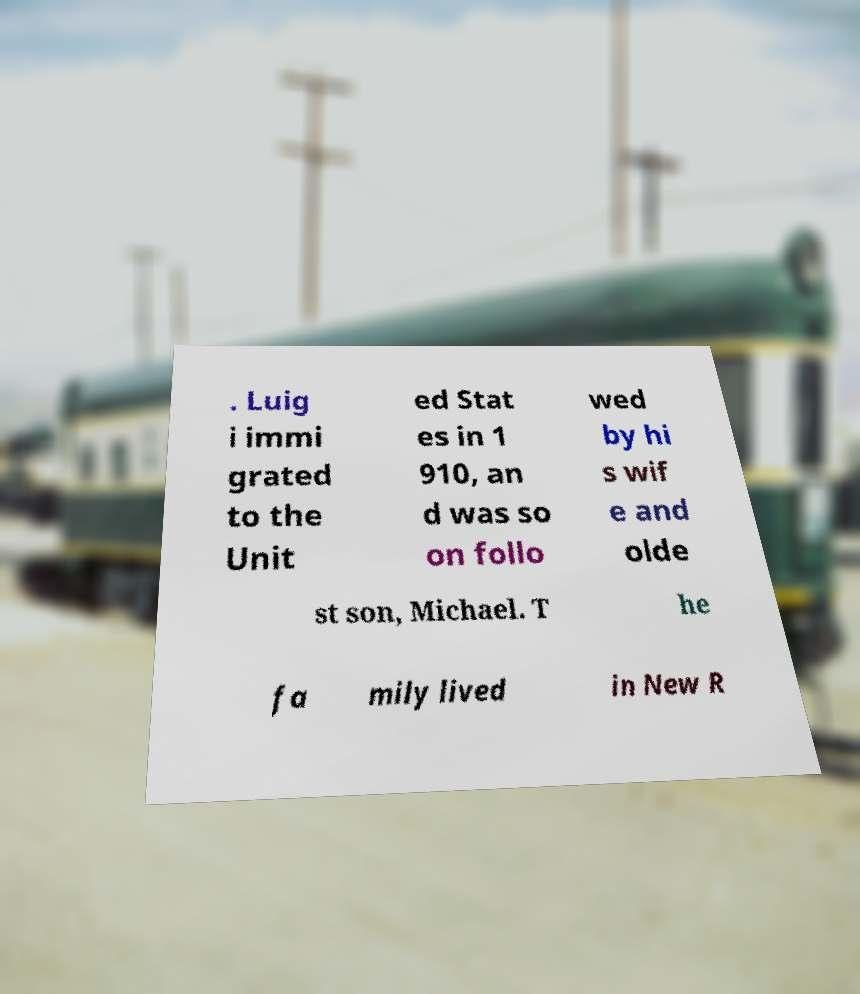For documentation purposes, I need the text within this image transcribed. Could you provide that? . Luig i immi grated to the Unit ed Stat es in 1 910, an d was so on follo wed by hi s wif e and olde st son, Michael. T he fa mily lived in New R 